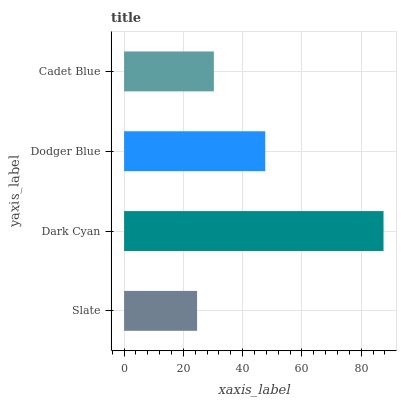Is Slate the minimum?
Answer yes or no. Yes. Is Dark Cyan the maximum?
Answer yes or no. Yes. Is Dodger Blue the minimum?
Answer yes or no. No. Is Dodger Blue the maximum?
Answer yes or no. No. Is Dark Cyan greater than Dodger Blue?
Answer yes or no. Yes. Is Dodger Blue less than Dark Cyan?
Answer yes or no. Yes. Is Dodger Blue greater than Dark Cyan?
Answer yes or no. No. Is Dark Cyan less than Dodger Blue?
Answer yes or no. No. Is Dodger Blue the high median?
Answer yes or no. Yes. Is Cadet Blue the low median?
Answer yes or no. Yes. Is Dark Cyan the high median?
Answer yes or no. No. Is Dark Cyan the low median?
Answer yes or no. No. 